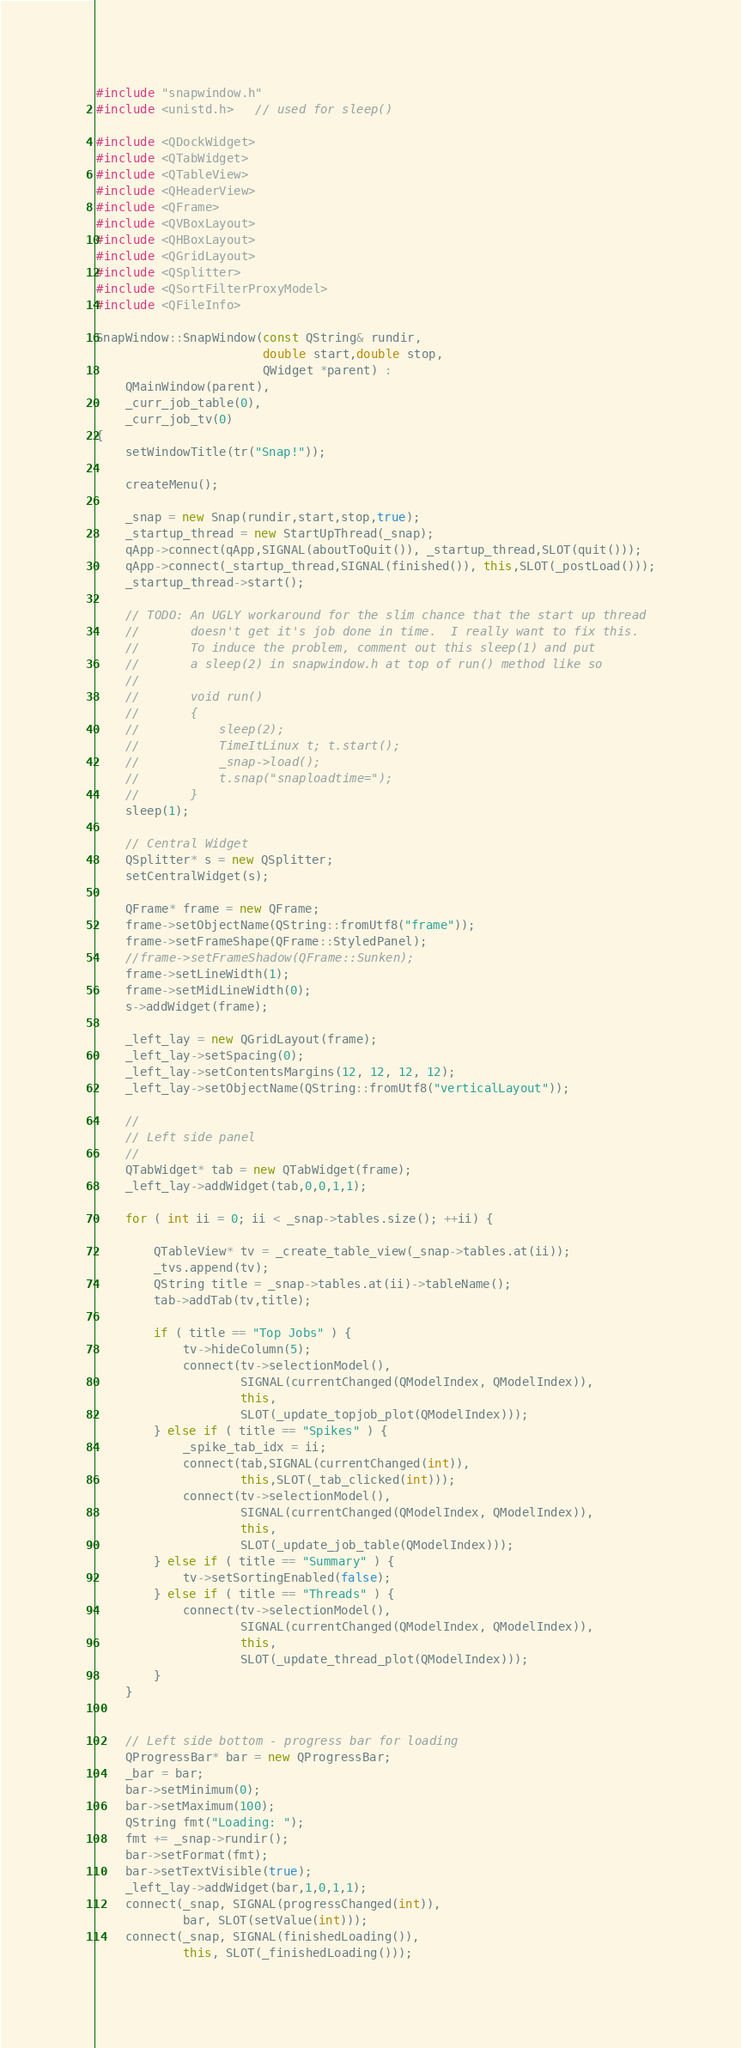Convert code to text. <code><loc_0><loc_0><loc_500><loc_500><_C++_>#include "snapwindow.h"
#include <unistd.h>   // used for sleep()

#include <QDockWidget>
#include <QTabWidget>
#include <QTableView>
#include <QHeaderView>
#include <QFrame>
#include <QVBoxLayout>
#include <QHBoxLayout>
#include <QGridLayout>
#include <QSplitter>
#include <QSortFilterProxyModel>
#include <QFileInfo>

SnapWindow::SnapWindow(const QString& rundir,
                       double start,double stop,
                       QWidget *parent) :
    QMainWindow(parent),
    _curr_job_table(0),
    _curr_job_tv(0)
{
    setWindowTitle(tr("Snap!"));

    createMenu();

    _snap = new Snap(rundir,start,stop,true);
    _startup_thread = new StartUpThread(_snap);
    qApp->connect(qApp,SIGNAL(aboutToQuit()), _startup_thread,SLOT(quit()));
    qApp->connect(_startup_thread,SIGNAL(finished()), this,SLOT(_postLoad()));
    _startup_thread->start();

    // TODO: An UGLY workaround for the slim chance that the start up thread
    //       doesn't get it's job done in time.  I really want to fix this.
    //       To induce the problem, comment out this sleep(1) and put
    //       a sleep(2) in snapwindow.h at top of run() method like so
    //
    //       void run()
    //       {
    //           sleep(2);
    //           TimeItLinux t; t.start();
    //           _snap->load();
    //           t.snap("snaploadtime=");
    //       }
    sleep(1);

    // Central Widget
    QSplitter* s = new QSplitter;
    setCentralWidget(s);

    QFrame* frame = new QFrame;
    frame->setObjectName(QString::fromUtf8("frame"));
    frame->setFrameShape(QFrame::StyledPanel);
    //frame->setFrameShadow(QFrame::Sunken);
    frame->setLineWidth(1);
    frame->setMidLineWidth(0);
    s->addWidget(frame);

    _left_lay = new QGridLayout(frame);
    _left_lay->setSpacing(0);
    _left_lay->setContentsMargins(12, 12, 12, 12);
    _left_lay->setObjectName(QString::fromUtf8("verticalLayout"));

    //
    // Left side panel
    //
    QTabWidget* tab = new QTabWidget(frame);
    _left_lay->addWidget(tab,0,0,1,1);

    for ( int ii = 0; ii < _snap->tables.size(); ++ii) {

        QTableView* tv = _create_table_view(_snap->tables.at(ii));
        _tvs.append(tv);
        QString title = _snap->tables.at(ii)->tableName();
        tab->addTab(tv,title);

        if ( title == "Top Jobs" ) {
            tv->hideColumn(5);
            connect(tv->selectionModel(),
                    SIGNAL(currentChanged(QModelIndex, QModelIndex)),
                    this,
                    SLOT(_update_topjob_plot(QModelIndex)));
        } else if ( title == "Spikes" ) {
            _spike_tab_idx = ii;
            connect(tab,SIGNAL(currentChanged(int)),
                    this,SLOT(_tab_clicked(int)));
            connect(tv->selectionModel(),
                    SIGNAL(currentChanged(QModelIndex, QModelIndex)),
                    this,
                    SLOT(_update_job_table(QModelIndex)));
        } else if ( title == "Summary" ) {
            tv->setSortingEnabled(false);
        } else if ( title == "Threads" ) {
            connect(tv->selectionModel(),
                    SIGNAL(currentChanged(QModelIndex, QModelIndex)),
                    this,
                    SLOT(_update_thread_plot(QModelIndex)));
        }
    }


    // Left side bottom - progress bar for loading
    QProgressBar* bar = new QProgressBar;
    _bar = bar;
    bar->setMinimum(0);
    bar->setMaximum(100);
    QString fmt("Loading: ");
    fmt += _snap->rundir();
    bar->setFormat(fmt);
    bar->setTextVisible(true);
    _left_lay->addWidget(bar,1,0,1,1);
    connect(_snap, SIGNAL(progressChanged(int)),
            bar, SLOT(setValue(int)));
    connect(_snap, SIGNAL(finishedLoading()),
            this, SLOT(_finishedLoading()));</code> 